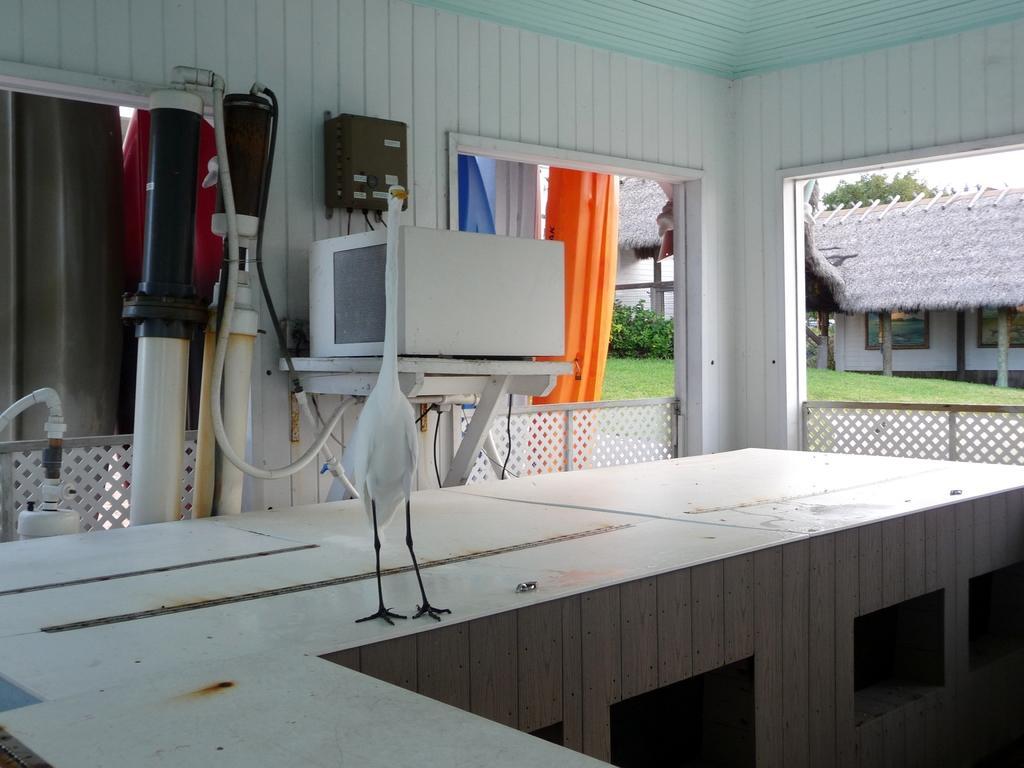In one or two sentences, can you explain what this image depicts? In the center of the image there is a bird on the table. On the right side of the image we can see a window, wooden fencing and a hut. On the left side of the image we can see some cylinders, window and a table. In the background there are trees, grass and sky. 